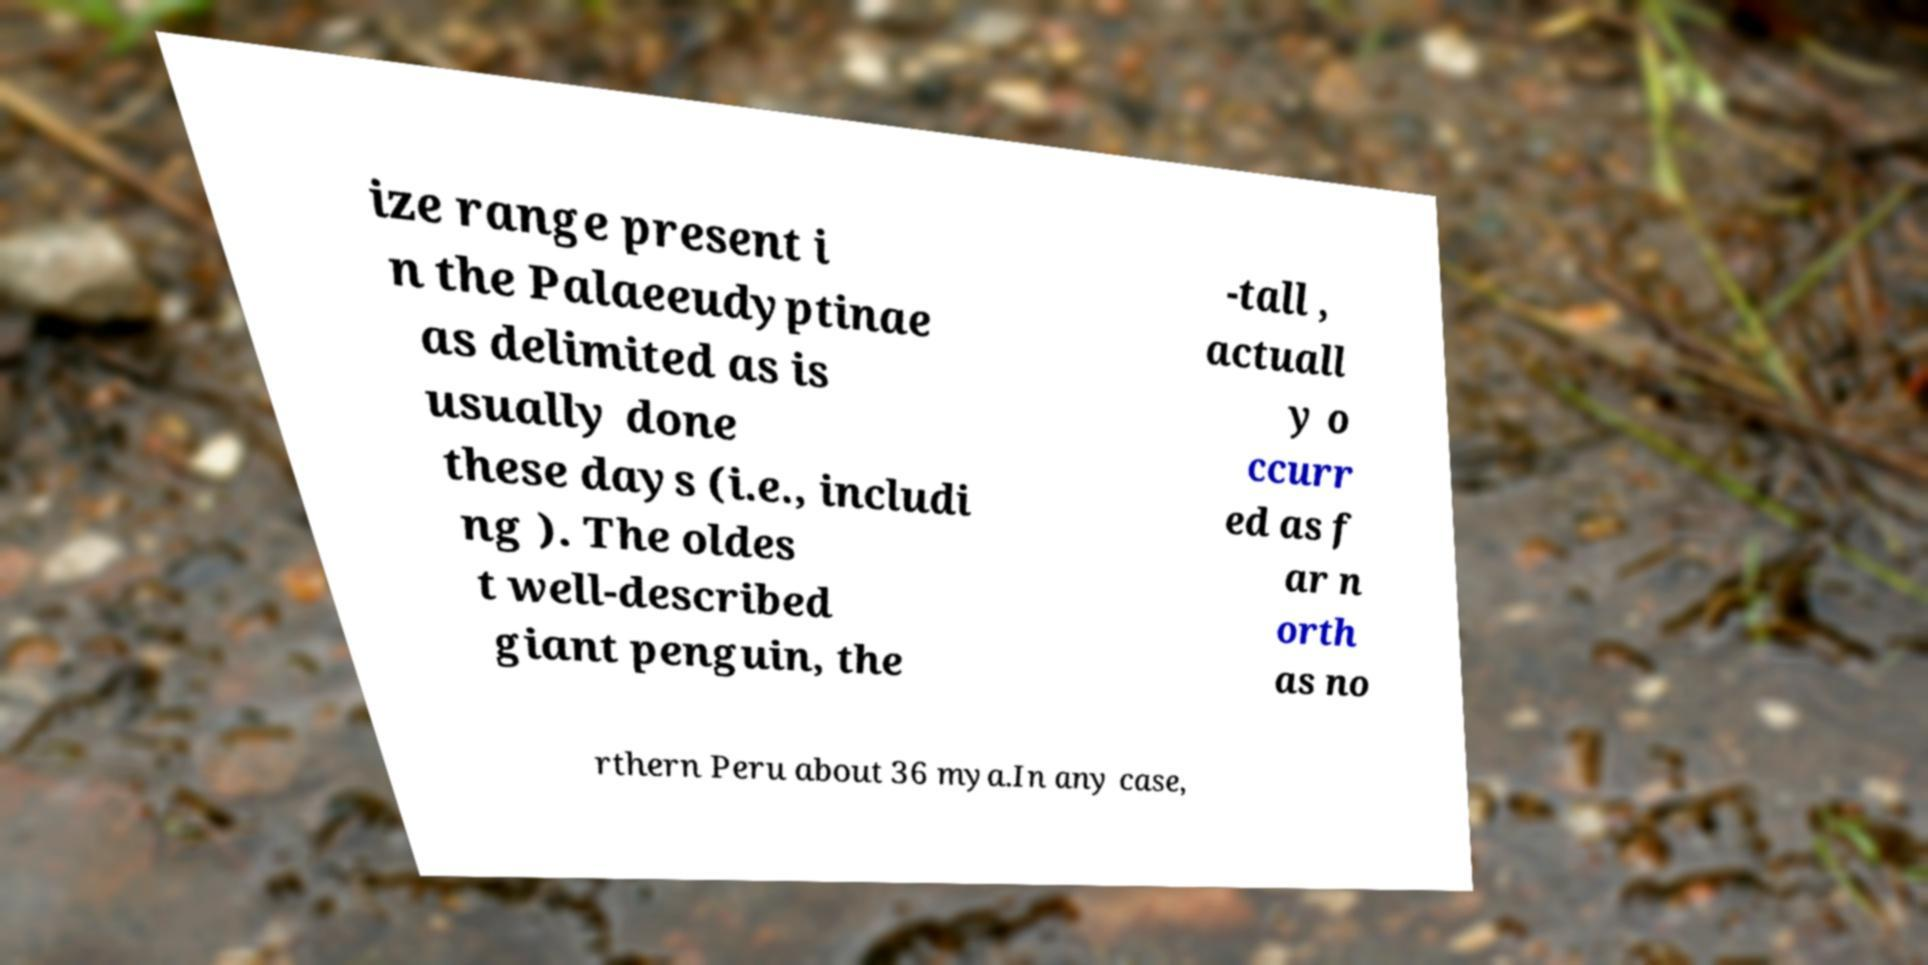For documentation purposes, I need the text within this image transcribed. Could you provide that? ize range present i n the Palaeeudyptinae as delimited as is usually done these days (i.e., includi ng ). The oldes t well-described giant penguin, the -tall , actuall y o ccurr ed as f ar n orth as no rthern Peru about 36 mya.In any case, 